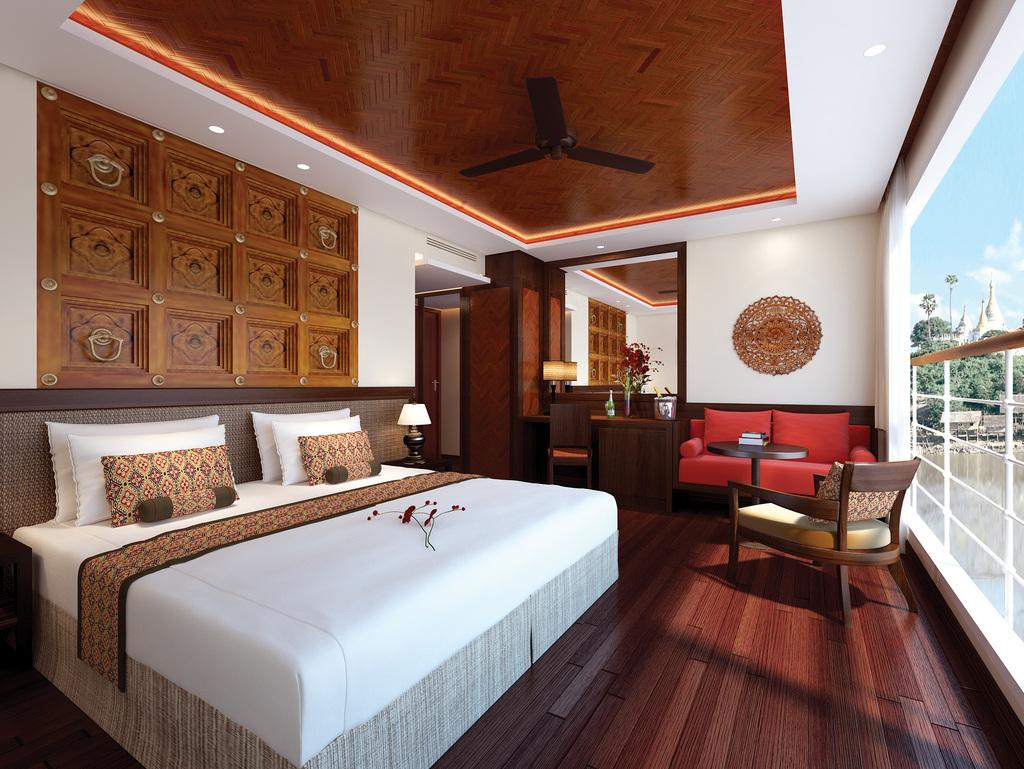Where is the setting of the image? The image is inside a room. What furniture is present in the room? There is a bed, pillows, a lamp, a fan, lights, and chairs in the room. What can be seen through the glass window in the room? Trees and the sky are visible through the glass window. What is the weather like outside the room? Clouds are visible in the sky, suggesting a partly cloudy day. What type of badge is hanging from the tree outside the room? There is no tree or badge present in the image; it is an indoor room with a glass window. Can you describe the swing that is attached to the fan in the room? There is no swing attached to the fan in the room; only a bed, pillows, a lamp, lights, and chairs are present. 